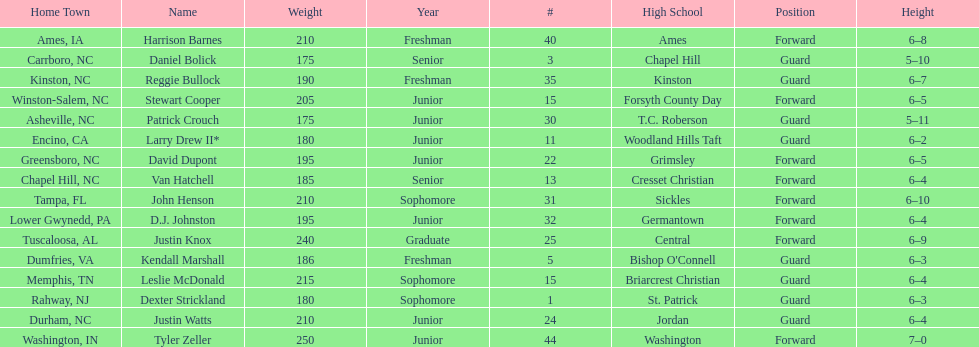How many players are not a junior? 9. 